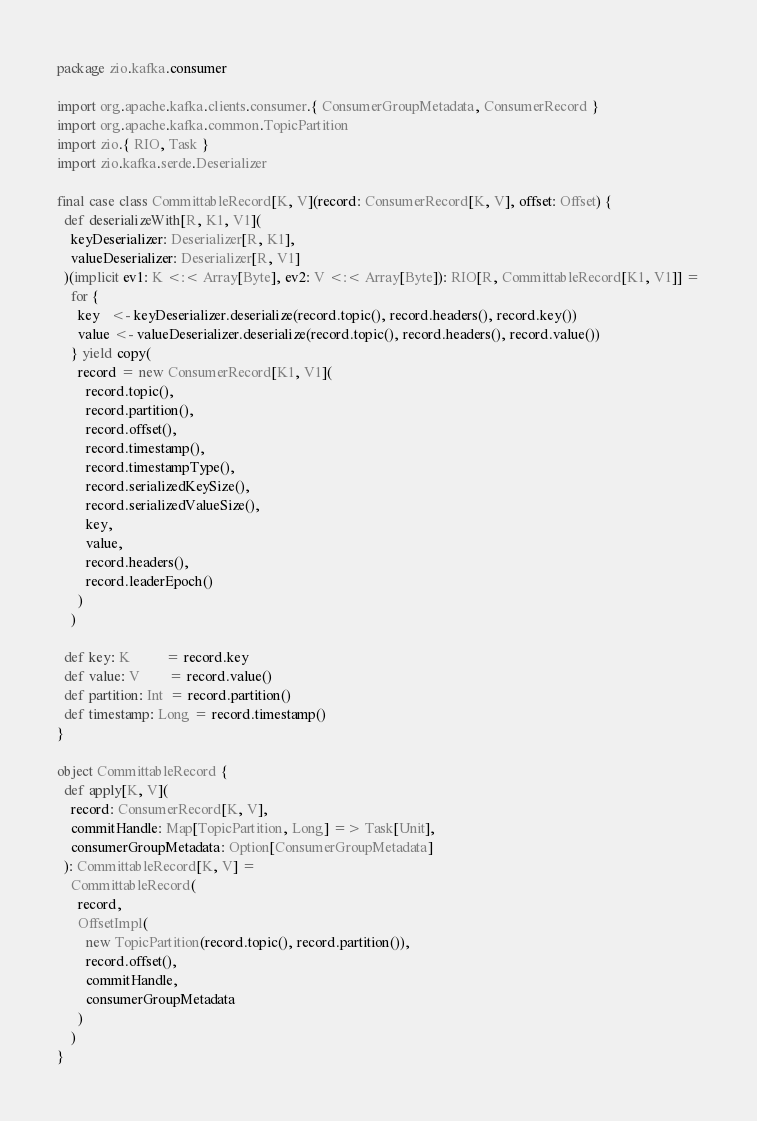<code> <loc_0><loc_0><loc_500><loc_500><_Scala_>package zio.kafka.consumer

import org.apache.kafka.clients.consumer.{ ConsumerGroupMetadata, ConsumerRecord }
import org.apache.kafka.common.TopicPartition
import zio.{ RIO, Task }
import zio.kafka.serde.Deserializer

final case class CommittableRecord[K, V](record: ConsumerRecord[K, V], offset: Offset) {
  def deserializeWith[R, K1, V1](
    keyDeserializer: Deserializer[R, K1],
    valueDeserializer: Deserializer[R, V1]
  )(implicit ev1: K <:< Array[Byte], ev2: V <:< Array[Byte]): RIO[R, CommittableRecord[K1, V1]] =
    for {
      key   <- keyDeserializer.deserialize(record.topic(), record.headers(), record.key())
      value <- valueDeserializer.deserialize(record.topic(), record.headers(), record.value())
    } yield copy(
      record = new ConsumerRecord[K1, V1](
        record.topic(),
        record.partition(),
        record.offset(),
        record.timestamp(),
        record.timestampType(),
        record.serializedKeySize(),
        record.serializedValueSize(),
        key,
        value,
        record.headers(),
        record.leaderEpoch()
      )
    )

  def key: K          = record.key
  def value: V        = record.value()
  def partition: Int  = record.partition()
  def timestamp: Long = record.timestamp()
}

object CommittableRecord {
  def apply[K, V](
    record: ConsumerRecord[K, V],
    commitHandle: Map[TopicPartition, Long] => Task[Unit],
    consumerGroupMetadata: Option[ConsumerGroupMetadata]
  ): CommittableRecord[K, V] =
    CommittableRecord(
      record,
      OffsetImpl(
        new TopicPartition(record.topic(), record.partition()),
        record.offset(),
        commitHandle,
        consumerGroupMetadata
      )
    )
}
</code> 